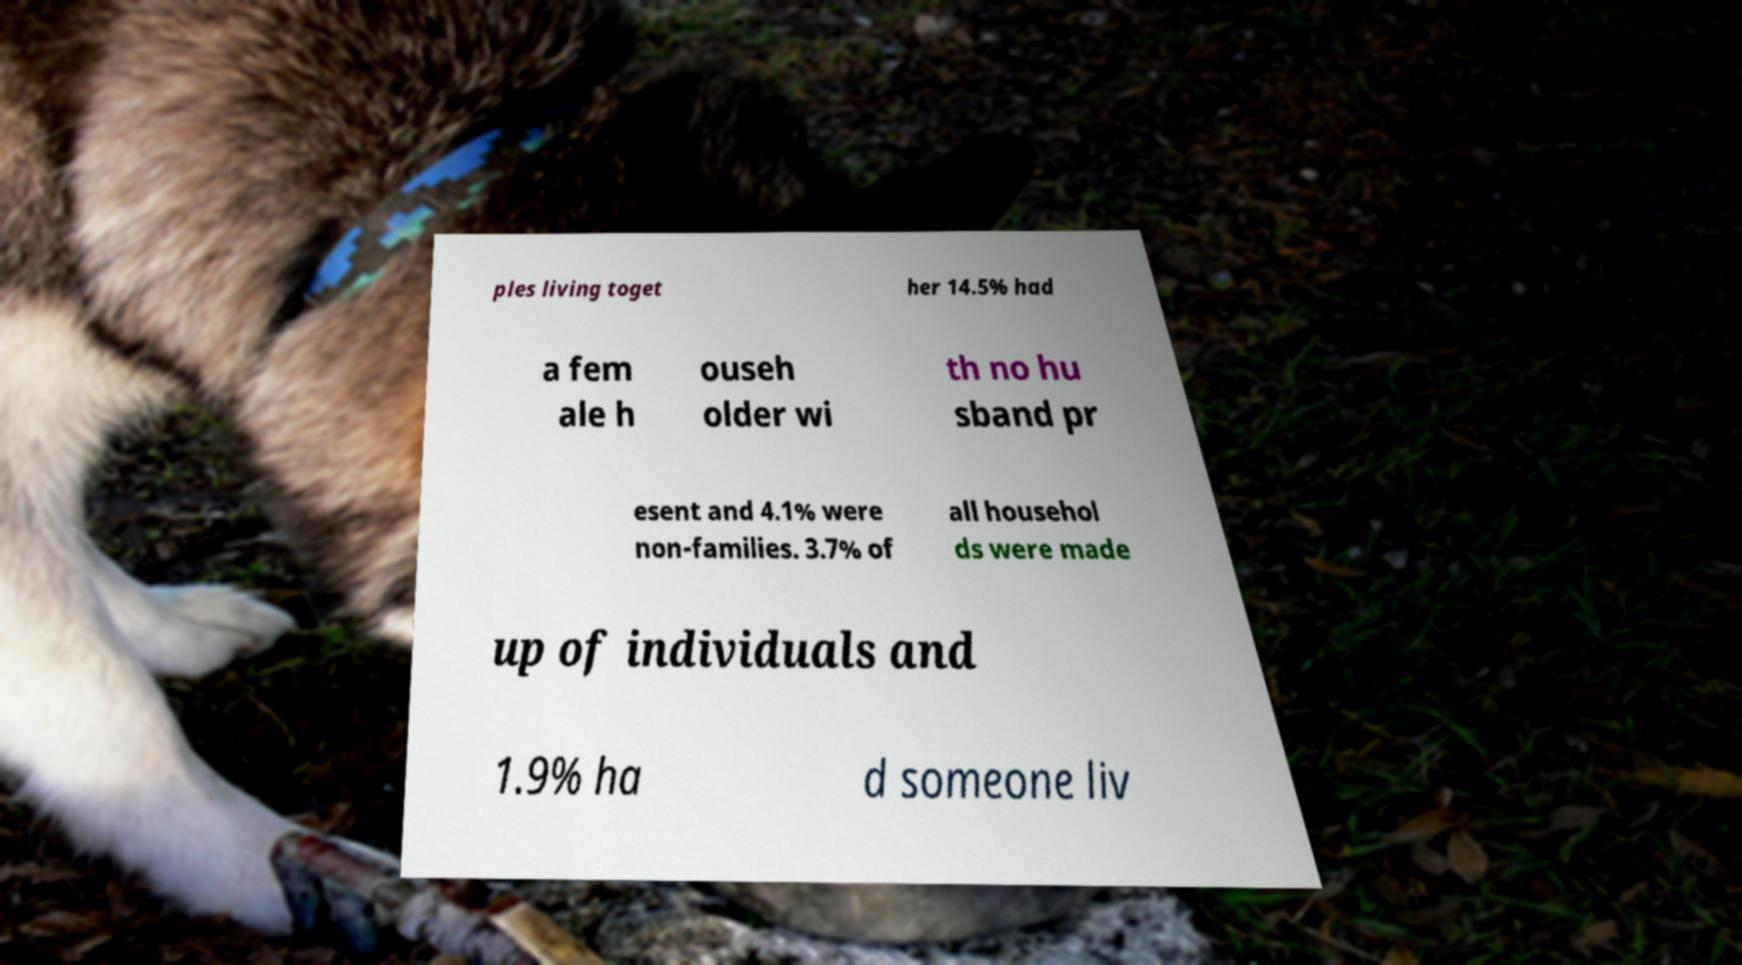Could you extract and type out the text from this image? ples living toget her 14.5% had a fem ale h ouseh older wi th no hu sband pr esent and 4.1% were non-families. 3.7% of all househol ds were made up of individuals and 1.9% ha d someone liv 